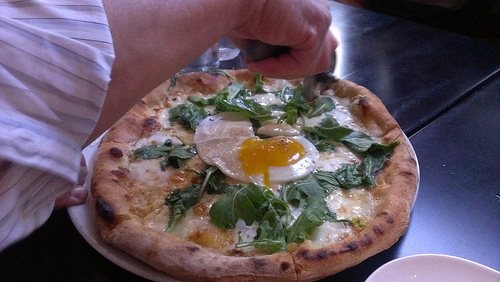What is the food to the left of the spinach that is on the right called? The food to the left of the spinach on the right is an egg. 